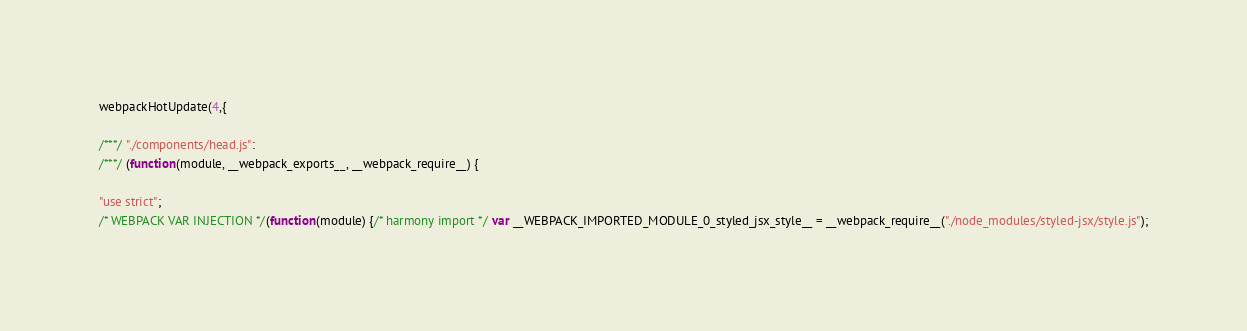Convert code to text. <code><loc_0><loc_0><loc_500><loc_500><_JavaScript_>webpackHotUpdate(4,{

/***/ "./components/head.js":
/***/ (function(module, __webpack_exports__, __webpack_require__) {

"use strict";
/* WEBPACK VAR INJECTION */(function(module) {/* harmony import */ var __WEBPACK_IMPORTED_MODULE_0_styled_jsx_style__ = __webpack_require__("./node_modules/styled-jsx/style.js");</code> 